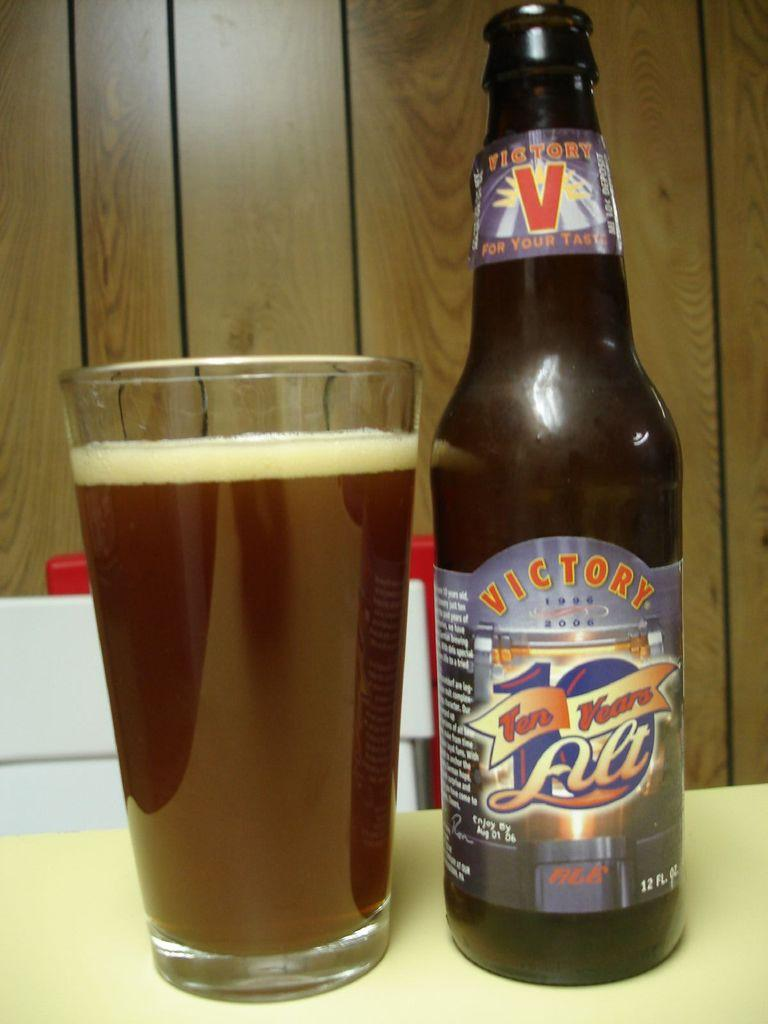<image>
Give a short and clear explanation of the subsequent image. Bottle of Victory beer next to a full cup of beer. 